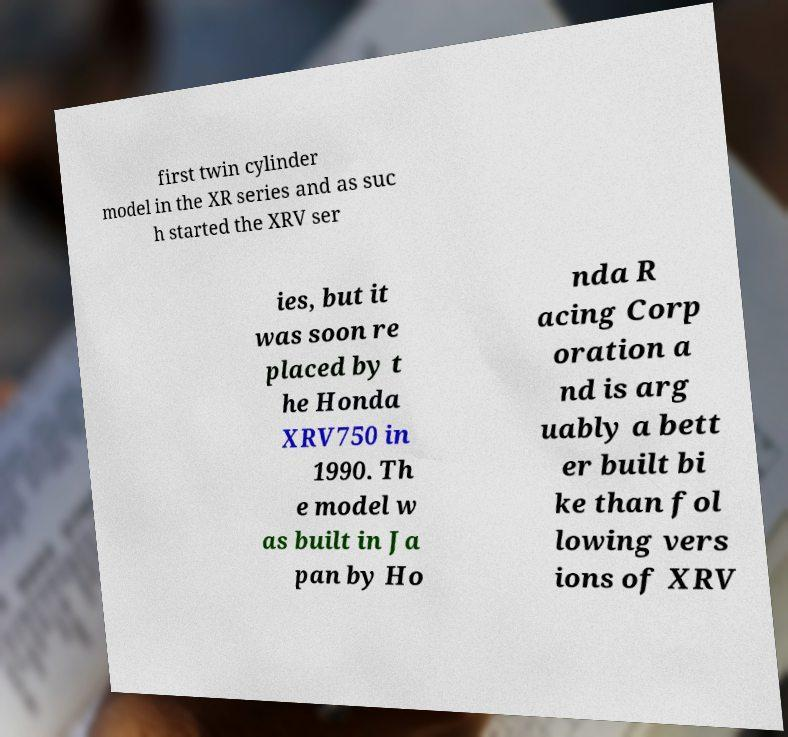I need the written content from this picture converted into text. Can you do that? first twin cylinder model in the XR series and as suc h started the XRV ser ies, but it was soon re placed by t he Honda XRV750 in 1990. Th e model w as built in Ja pan by Ho nda R acing Corp oration a nd is arg uably a bett er built bi ke than fol lowing vers ions of XRV 